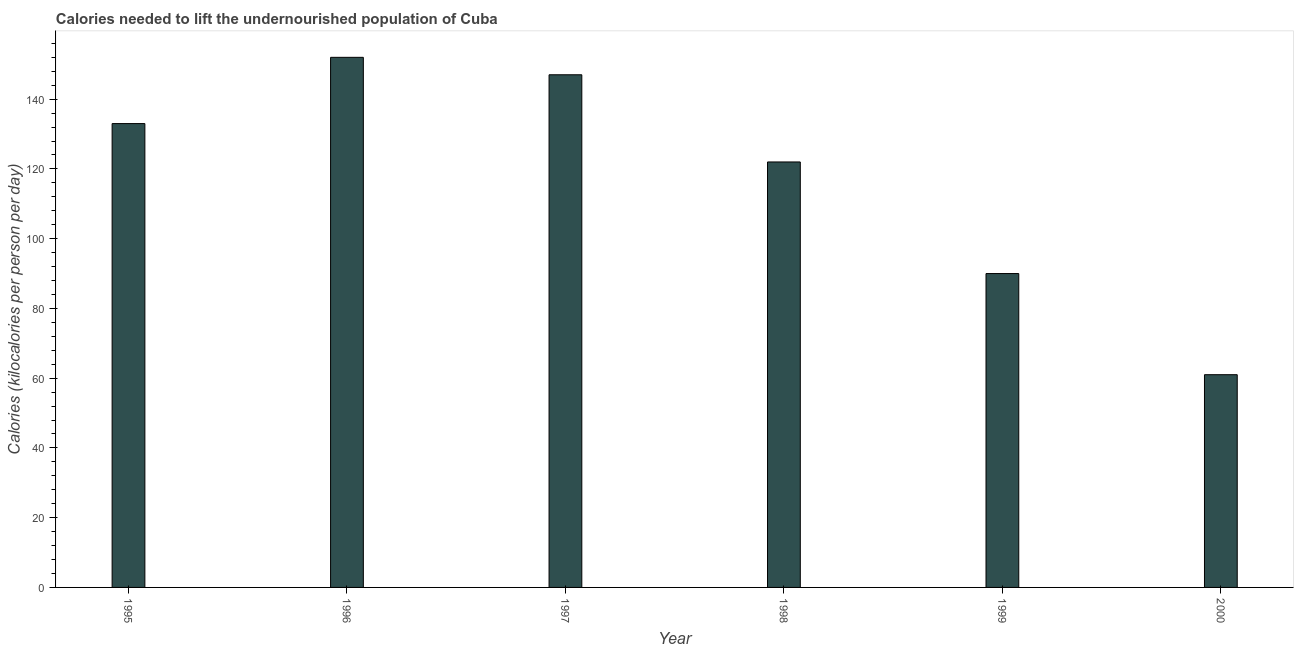What is the title of the graph?
Offer a terse response. Calories needed to lift the undernourished population of Cuba. What is the label or title of the X-axis?
Your answer should be very brief. Year. What is the label or title of the Y-axis?
Ensure brevity in your answer.  Calories (kilocalories per person per day). What is the depth of food deficit in 1998?
Keep it short and to the point. 122. Across all years, what is the maximum depth of food deficit?
Provide a short and direct response. 152. In which year was the depth of food deficit maximum?
Offer a very short reply. 1996. In which year was the depth of food deficit minimum?
Provide a short and direct response. 2000. What is the sum of the depth of food deficit?
Give a very brief answer. 705. What is the average depth of food deficit per year?
Offer a terse response. 117. What is the median depth of food deficit?
Give a very brief answer. 127.5. In how many years, is the depth of food deficit greater than 128 kilocalories?
Provide a short and direct response. 3. What is the ratio of the depth of food deficit in 1996 to that in 1998?
Offer a terse response. 1.25. Is the depth of food deficit in 1995 less than that in 1996?
Your answer should be compact. Yes. Is the difference between the depth of food deficit in 1996 and 1999 greater than the difference between any two years?
Your response must be concise. No. What is the difference between the highest and the lowest depth of food deficit?
Offer a terse response. 91. How many bars are there?
Give a very brief answer. 6. Are all the bars in the graph horizontal?
Ensure brevity in your answer.  No. How many years are there in the graph?
Offer a very short reply. 6. What is the Calories (kilocalories per person per day) in 1995?
Make the answer very short. 133. What is the Calories (kilocalories per person per day) of 1996?
Provide a succinct answer. 152. What is the Calories (kilocalories per person per day) in 1997?
Your response must be concise. 147. What is the Calories (kilocalories per person per day) in 1998?
Offer a very short reply. 122. What is the Calories (kilocalories per person per day) in 1999?
Offer a very short reply. 90. What is the difference between the Calories (kilocalories per person per day) in 1995 and 1996?
Make the answer very short. -19. What is the difference between the Calories (kilocalories per person per day) in 1995 and 1998?
Give a very brief answer. 11. What is the difference between the Calories (kilocalories per person per day) in 1995 and 1999?
Your answer should be compact. 43. What is the difference between the Calories (kilocalories per person per day) in 1995 and 2000?
Offer a terse response. 72. What is the difference between the Calories (kilocalories per person per day) in 1996 and 1998?
Your answer should be compact. 30. What is the difference between the Calories (kilocalories per person per day) in 1996 and 1999?
Your response must be concise. 62. What is the difference between the Calories (kilocalories per person per day) in 1996 and 2000?
Provide a succinct answer. 91. What is the difference between the Calories (kilocalories per person per day) in 1997 and 1998?
Provide a short and direct response. 25. What is the difference between the Calories (kilocalories per person per day) in 1999 and 2000?
Your answer should be very brief. 29. What is the ratio of the Calories (kilocalories per person per day) in 1995 to that in 1997?
Offer a very short reply. 0.91. What is the ratio of the Calories (kilocalories per person per day) in 1995 to that in 1998?
Your response must be concise. 1.09. What is the ratio of the Calories (kilocalories per person per day) in 1995 to that in 1999?
Your answer should be compact. 1.48. What is the ratio of the Calories (kilocalories per person per day) in 1995 to that in 2000?
Offer a very short reply. 2.18. What is the ratio of the Calories (kilocalories per person per day) in 1996 to that in 1997?
Your response must be concise. 1.03. What is the ratio of the Calories (kilocalories per person per day) in 1996 to that in 1998?
Make the answer very short. 1.25. What is the ratio of the Calories (kilocalories per person per day) in 1996 to that in 1999?
Your answer should be compact. 1.69. What is the ratio of the Calories (kilocalories per person per day) in 1996 to that in 2000?
Make the answer very short. 2.49. What is the ratio of the Calories (kilocalories per person per day) in 1997 to that in 1998?
Offer a terse response. 1.21. What is the ratio of the Calories (kilocalories per person per day) in 1997 to that in 1999?
Keep it short and to the point. 1.63. What is the ratio of the Calories (kilocalories per person per day) in 1997 to that in 2000?
Give a very brief answer. 2.41. What is the ratio of the Calories (kilocalories per person per day) in 1998 to that in 1999?
Offer a very short reply. 1.36. What is the ratio of the Calories (kilocalories per person per day) in 1998 to that in 2000?
Your answer should be compact. 2. What is the ratio of the Calories (kilocalories per person per day) in 1999 to that in 2000?
Offer a very short reply. 1.48. 